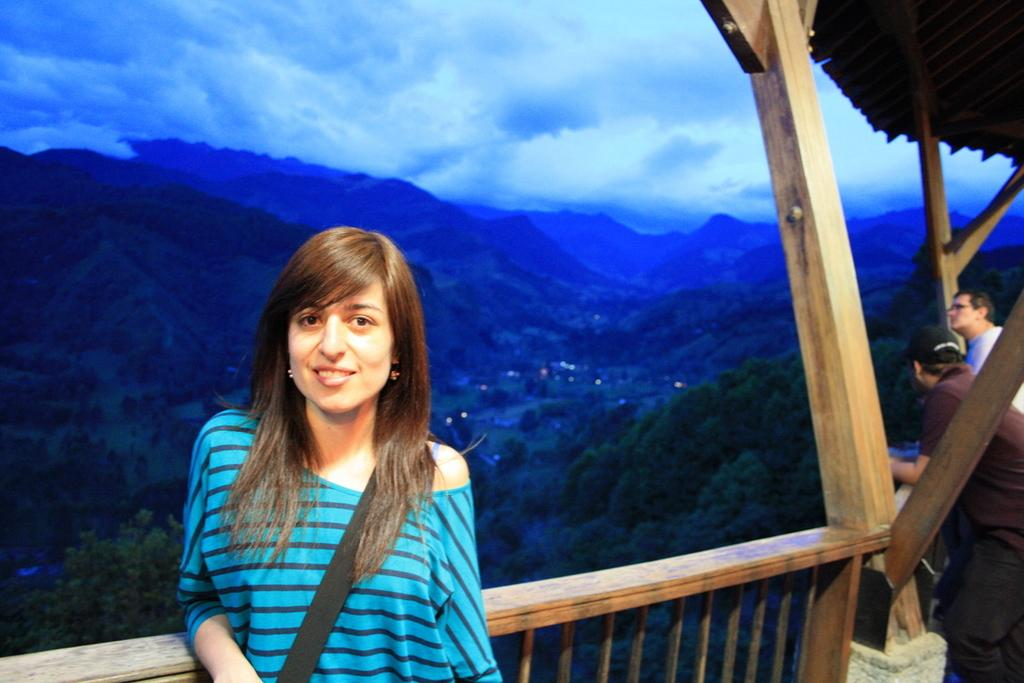What is the lady near in the image? The lady is standing near wooden railings in the image. What can be seen in the background of the image? Hills and the sky are visible in the background of the image. What is the condition of the sky in the image? Clouds are present in the sky in the image. What is on the right side of the image? There are people and wooden poles on the right side of the image. What type of coil is being used by the lady's father in the image? There is no father or coil present in the image. 